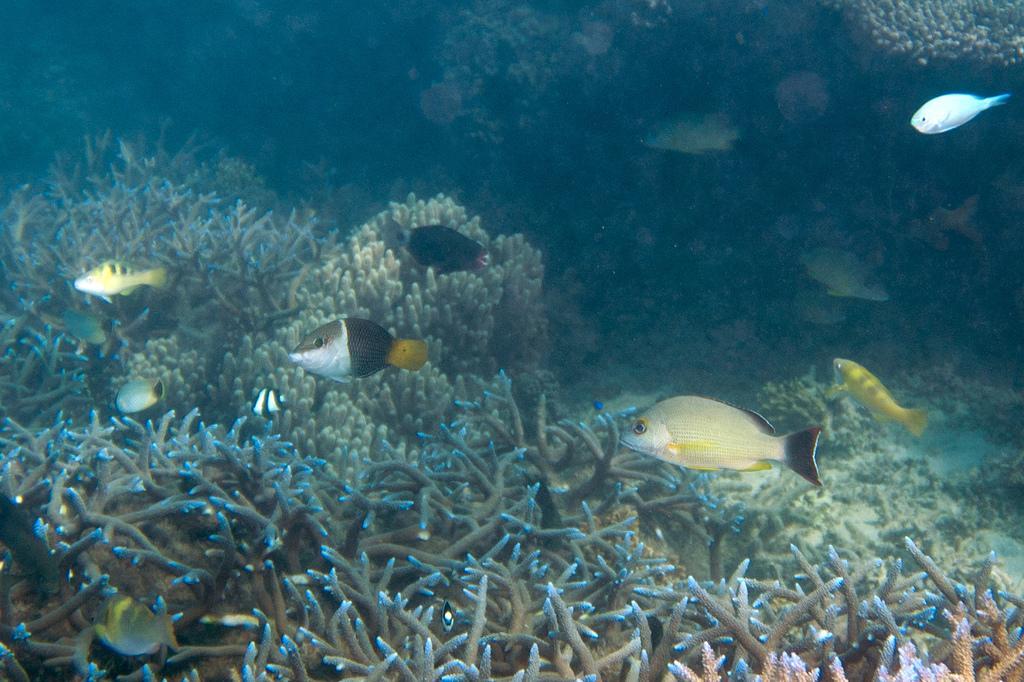Could you give a brief overview of what you see in this image? This is the image of the underground of the water. In the middle of this image, there are fish. At the bottom of this image, there is a fish and there are plants on the ground. In the background, there are fishes and there are plants. 